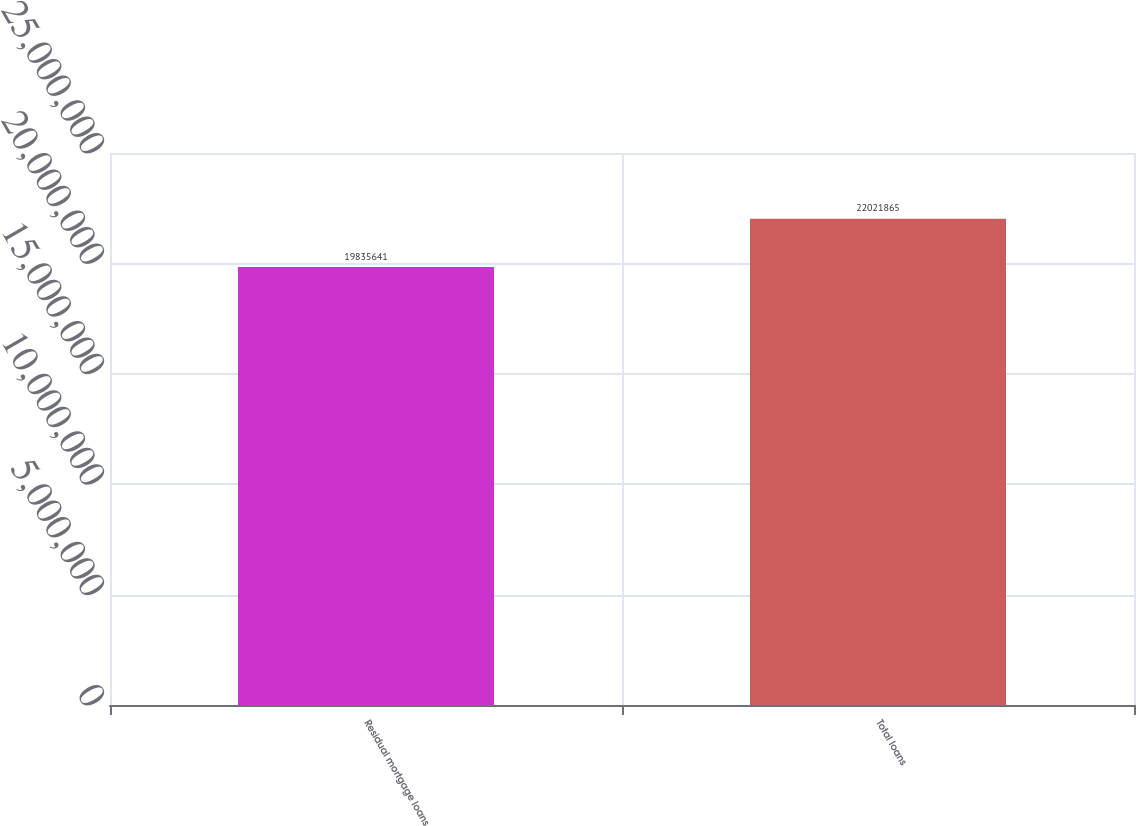<chart> <loc_0><loc_0><loc_500><loc_500><bar_chart><fcel>Residual mortgage loans<fcel>Total loans<nl><fcel>1.98356e+07<fcel>2.20219e+07<nl></chart> 